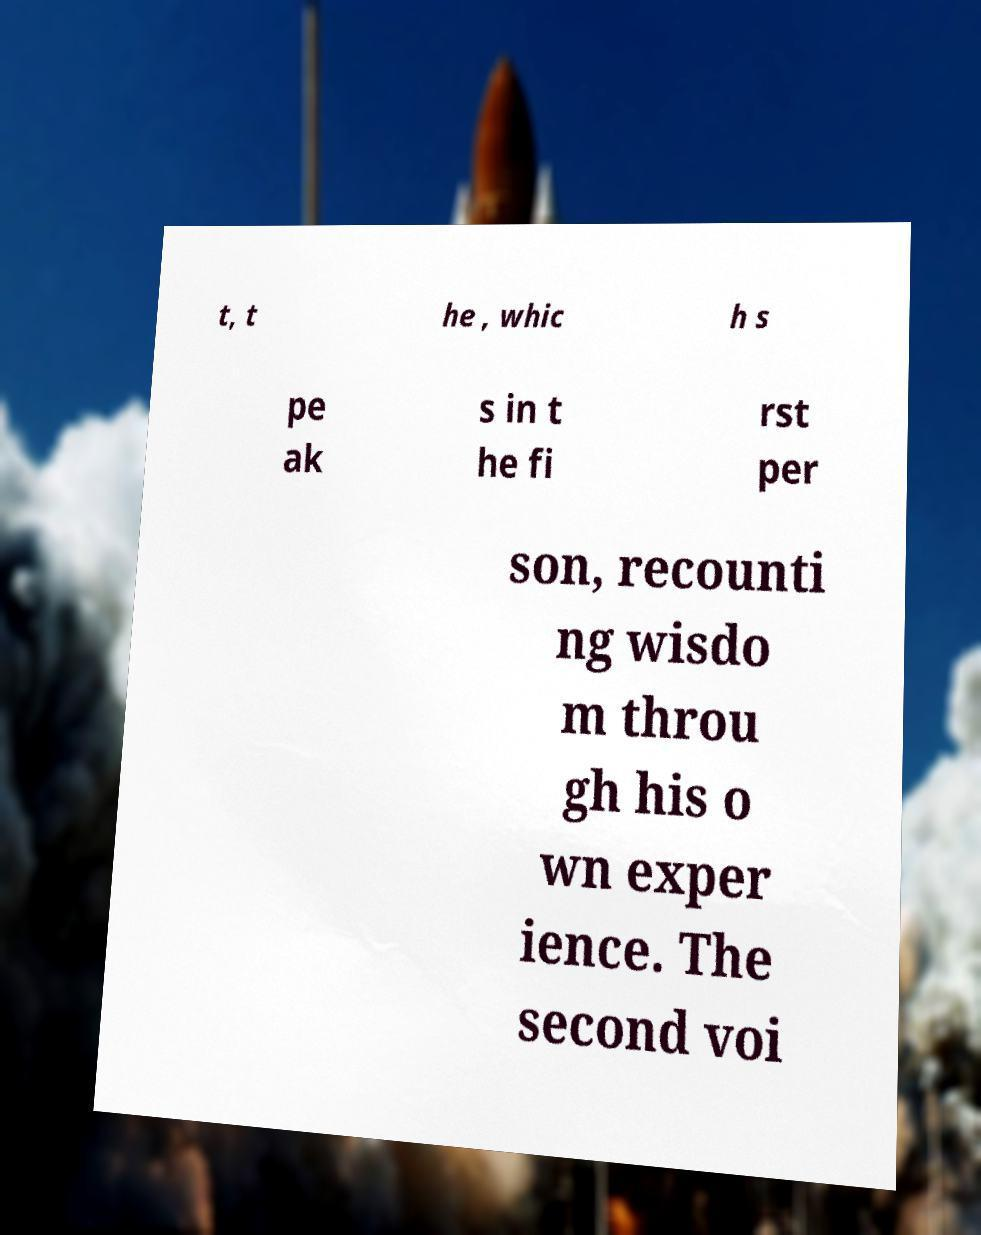Could you assist in decoding the text presented in this image and type it out clearly? t, t he , whic h s pe ak s in t he fi rst per son, recounti ng wisdo m throu gh his o wn exper ience. The second voi 